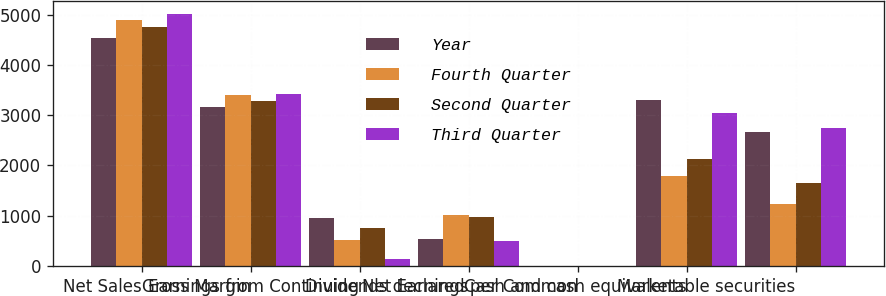Convert chart. <chart><loc_0><loc_0><loc_500><loc_500><stacked_bar_chart><ecel><fcel>Net Sales<fcel>Gross Margin<fcel>Earnings from Continuing<fcel>Net Earnings<fcel>Dividends declared per Common<fcel>Cash and cash equivalents<fcel>Marketable securities<nl><fcel>Year<fcel>4532<fcel>3165<fcel>961<fcel>533<fcel>0.28<fcel>3311<fcel>2671<nl><fcel>Fourth Quarter<fcel>4889<fcel>3406<fcel>523<fcel>1004<fcel>0.28<fcel>1798<fcel>1242<nl><fcel>Second Quarter<fcel>4767<fcel>3284<fcel>755<fcel>964<fcel>0.28<fcel>2129<fcel>1652<nl><fcel>Third Quarter<fcel>5019<fcel>3424<fcel>139<fcel>499<fcel>0.28<fcel>3050<fcel>2749<nl></chart> 